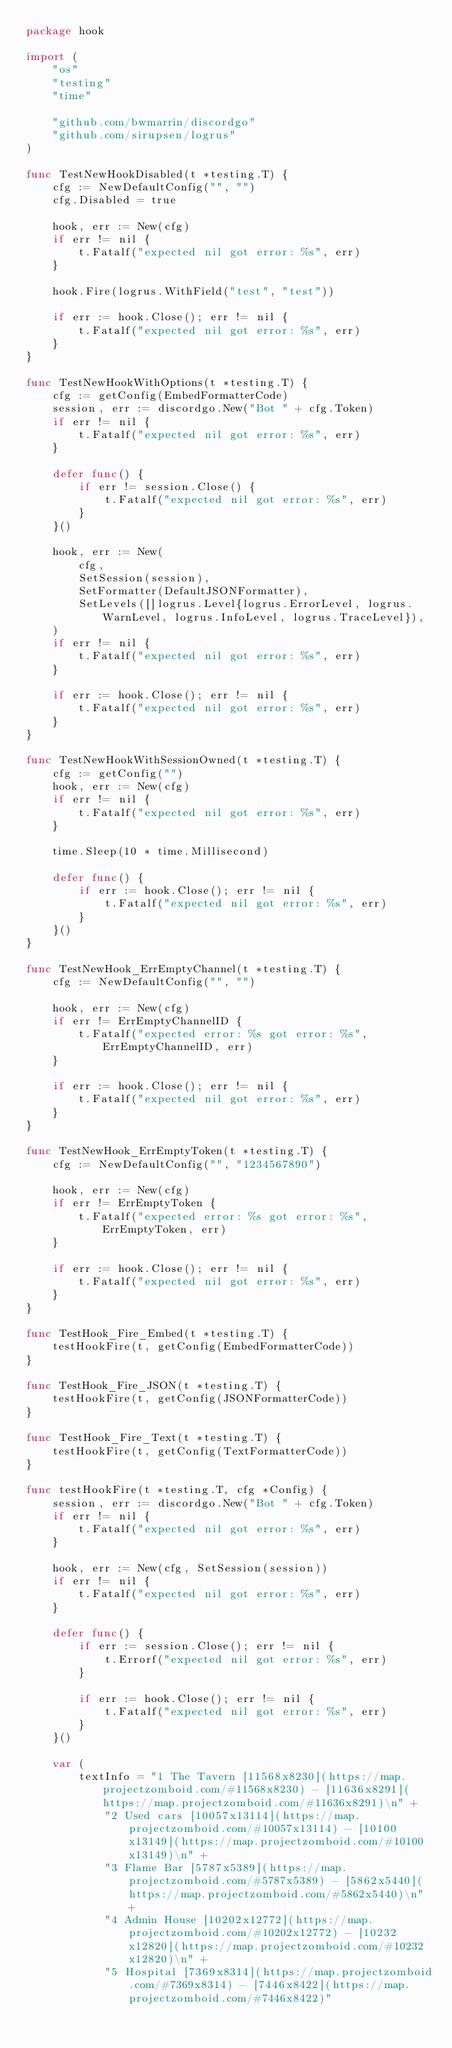<code> <loc_0><loc_0><loc_500><loc_500><_Go_>package hook

import (
	"os"
	"testing"
	"time"

	"github.com/bwmarrin/discordgo"
	"github.com/sirupsen/logrus"
)

func TestNewHookDisabled(t *testing.T) {
	cfg := NewDefaultConfig("", "")
	cfg.Disabled = true

	hook, err := New(cfg)
	if err != nil {
		t.Fatalf("expected nil got error: %s", err)
	}

	hook.Fire(logrus.WithField("test", "test"))

	if err := hook.Close(); err != nil {
		t.Fatalf("expected nil got error: %s", err)
	}
}

func TestNewHookWithOptions(t *testing.T) {
	cfg := getConfig(EmbedFormatterCode)
	session, err := discordgo.New("Bot " + cfg.Token)
	if err != nil {
		t.Fatalf("expected nil got error: %s", err)
	}

	defer func() {
		if err != session.Close() {
			t.Fatalf("expected nil got error: %s", err)
		}
	}()

	hook, err := New(
		cfg,
		SetSession(session),
		SetFormatter(DefaultJSONFormatter),
		SetLevels([]logrus.Level{logrus.ErrorLevel, logrus.WarnLevel, logrus.InfoLevel, logrus.TraceLevel}),
	)
	if err != nil {
		t.Fatalf("expected nil got error: %s", err)
	}

	if err := hook.Close(); err != nil {
		t.Fatalf("expected nil got error: %s", err)
	}
}

func TestNewHookWithSessionOwned(t *testing.T) {
	cfg := getConfig("")
	hook, err := New(cfg)
	if err != nil {
		t.Fatalf("expected nil got error: %s", err)
	}

	time.Sleep(10 * time.Millisecond)

	defer func() {
		if err := hook.Close(); err != nil {
			t.Fatalf("expected nil got error: %s", err)
		}
	}()
}

func TestNewHook_ErrEmptyChannel(t *testing.T) {
	cfg := NewDefaultConfig("", "")

	hook, err := New(cfg)
	if err != ErrEmptyChannelID {
		t.Fatalf("expected error: %s got error: %s", ErrEmptyChannelID, err)
	}

	if err := hook.Close(); err != nil {
		t.Fatalf("expected nil got error: %s", err)
	}
}

func TestNewHook_ErrEmptyToken(t *testing.T) {
	cfg := NewDefaultConfig("", "1234567890")

	hook, err := New(cfg)
	if err != ErrEmptyToken {
		t.Fatalf("expected error: %s got error: %s", ErrEmptyToken, err)
	}

	if err := hook.Close(); err != nil {
		t.Fatalf("expected nil got error: %s", err)
	}
}

func TestHook_Fire_Embed(t *testing.T) {
	testHookFire(t, getConfig(EmbedFormatterCode))
}

func TestHook_Fire_JSON(t *testing.T) {
	testHookFire(t, getConfig(JSONFormatterCode))
}

func TestHook_Fire_Text(t *testing.T) {
	testHookFire(t, getConfig(TextFormatterCode))
}

func testHookFire(t *testing.T, cfg *Config) {
	session, err := discordgo.New("Bot " + cfg.Token)
	if err != nil {
		t.Fatalf("expected nil got error: %s", err)
	}

	hook, err := New(cfg, SetSession(session))
	if err != nil {
		t.Fatalf("expected nil got error: %s", err)
	}

	defer func() {
		if err := session.Close(); err != nil {
			t.Errorf("expected nil got error: %s", err)
		}

		if err := hook.Close(); err != nil {
			t.Fatalf("expected nil got error: %s", err)
		}
	}()

	var (
		textInfo = "1 The Tavern [11568x8230](https://map.projectzomboid.com/#11568x8230) - [11636x8291](https://map.projectzomboid.com/#11636x8291)\n" +
			"2 Used cars [10057x13114](https://map.projectzomboid.com/#10057x13114) - [10100x13149](https://map.projectzomboid.com/#10100x13149)\n" +
			"3 Flame Bar [5787x5389](https://map.projectzomboid.com/#5787x5389) - [5862x5440](https://map.projectzomboid.com/#5862x5440)\n" +
			"4 Admin House [10202x12772](https://map.projectzomboid.com/#10202x12772) - [10232x12820](https://map.projectzomboid.com/#10232x12820)\n" +
			"5 Hospital [7369x8314](https://map.projectzomboid.com/#7369x8314) - [7446x8422](https://map.projectzomboid.com/#7446x8422)"
</code> 